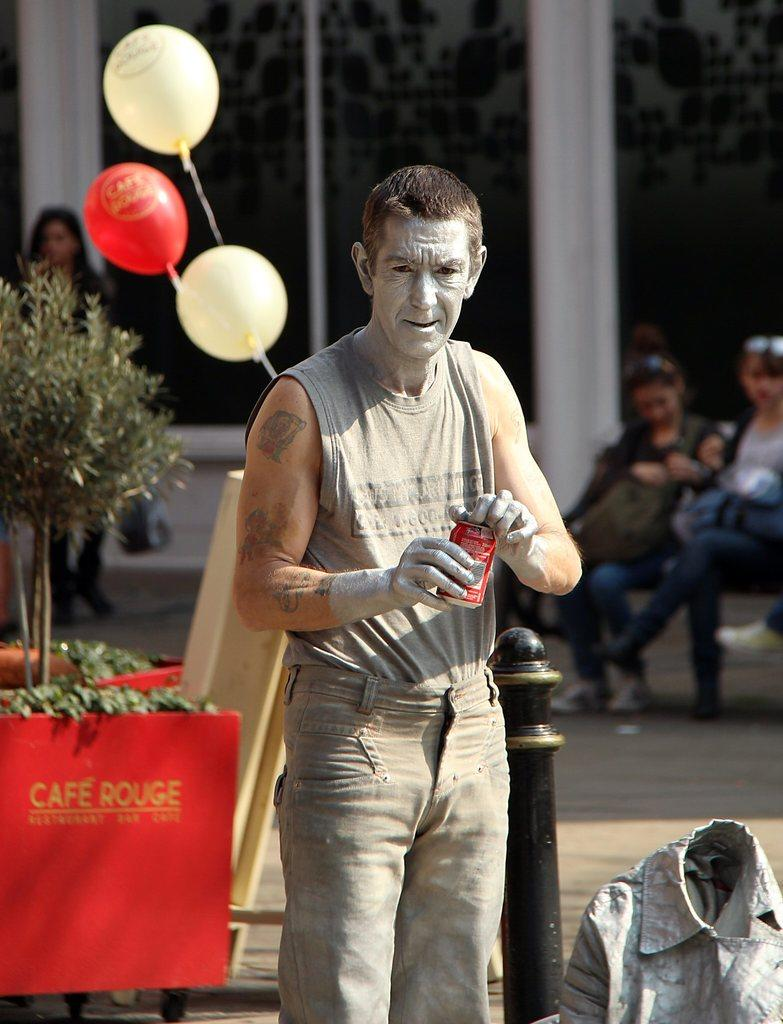Who is the main subject in the image? There is a man in the center of the image. What is the man holding in the image? The man is holding a tin. What can be seen in the background of the image? There are balloons, plants, persons, and a building in the background of the image. How many boats are visible in the image? There are no boats present in the image. What type of jar is the man holding in the image? The man is not holding a jar in the image; he is holding a tin. 